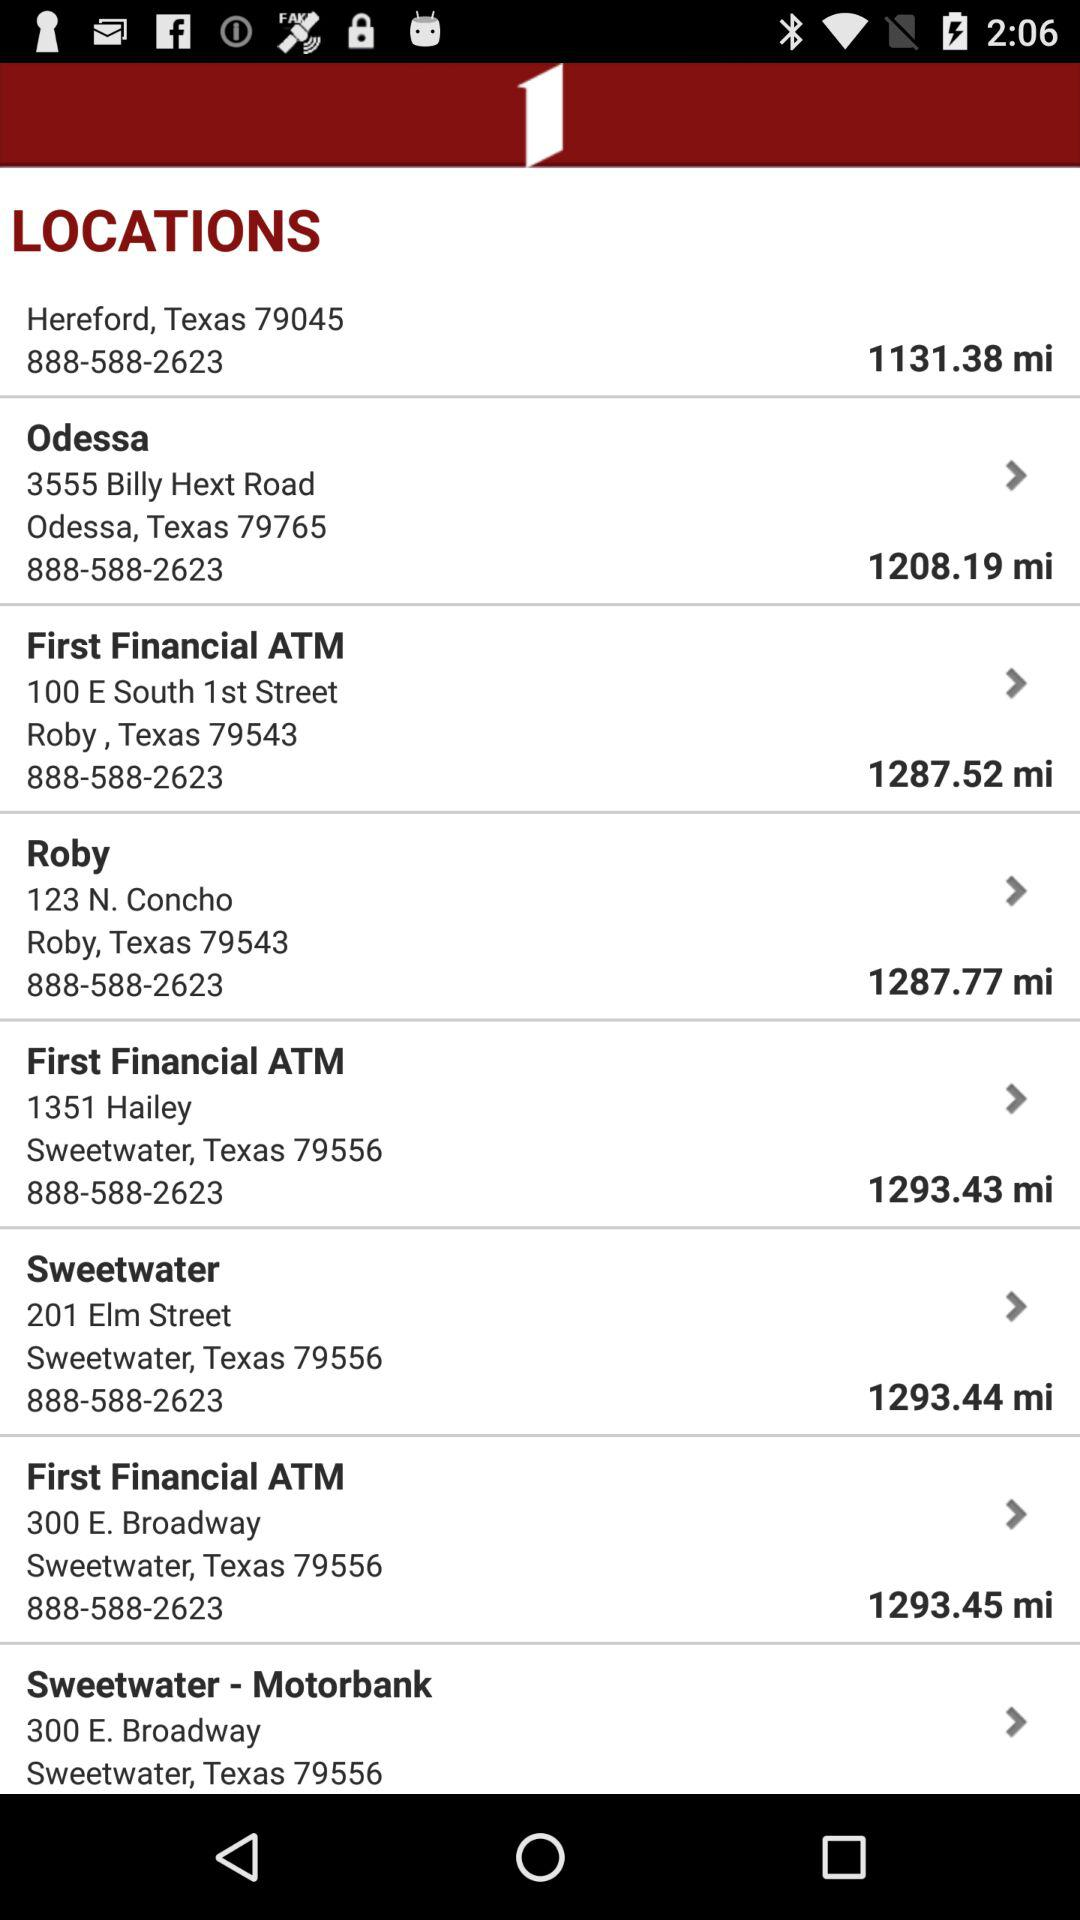What is the address of the "Sweetwater-Motorbank"? The address is 300 E. Broadway Sweetwater, Texas 79556. 